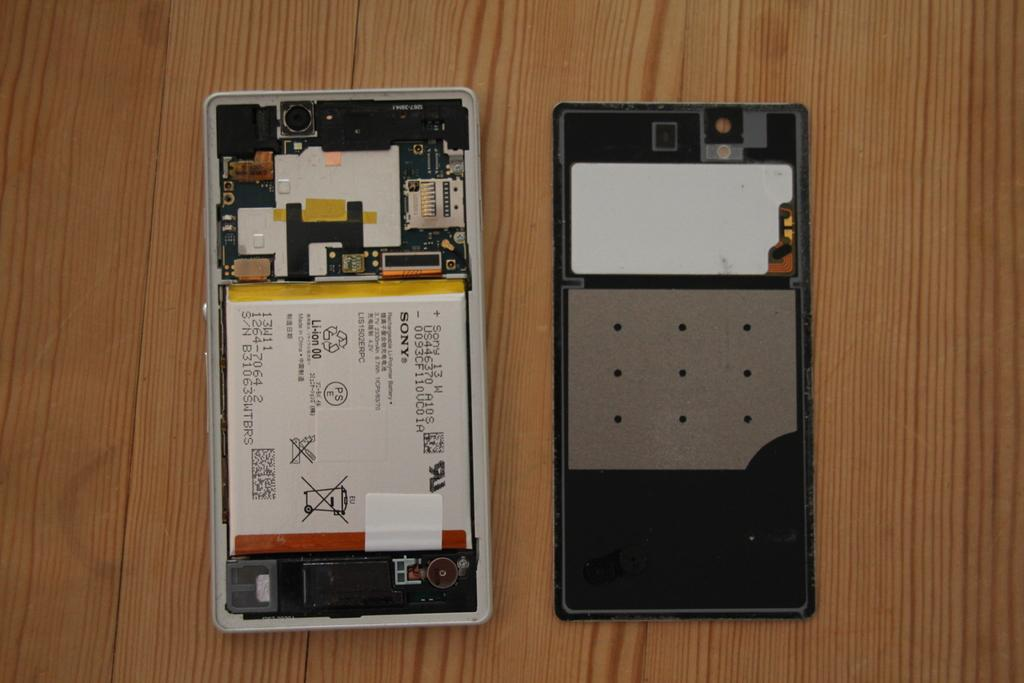<image>
Give a short and clear explanation of the subsequent image. A Sony phone has the back cover taken off. 